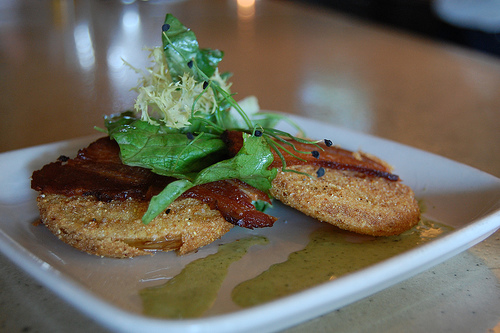<image>
Can you confirm if the lettuce is on the plate? Yes. Looking at the image, I can see the lettuce is positioned on top of the plate, with the plate providing support. 